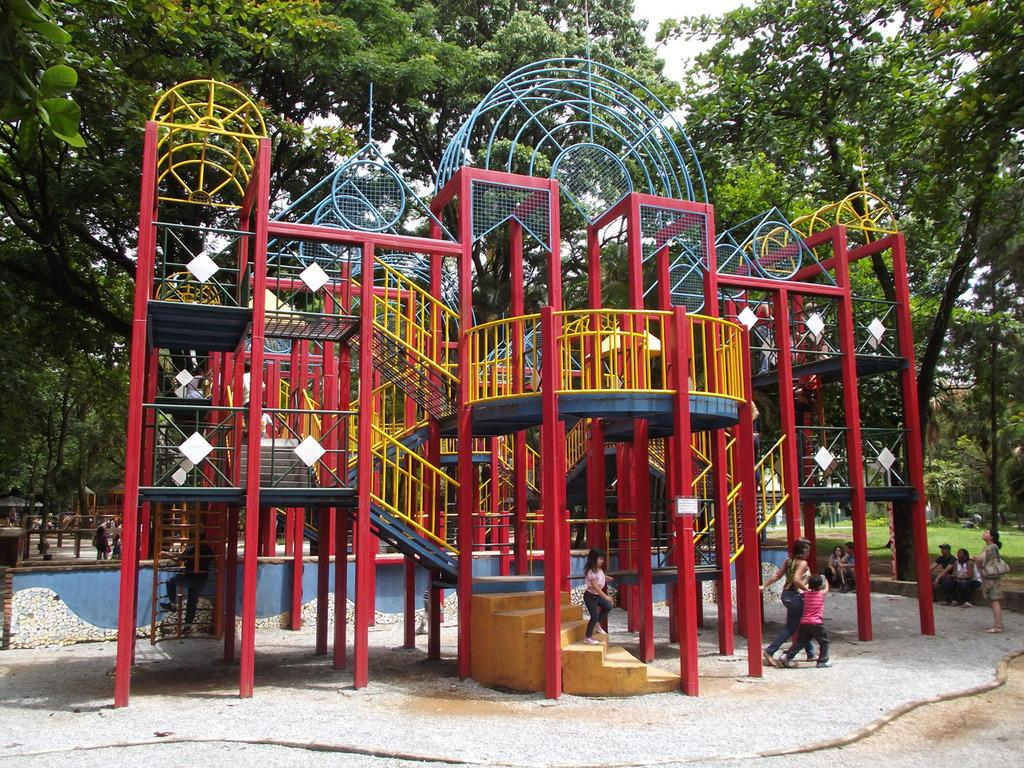What is the main subject of the image? The main subject of the image is a playground. Are there any people present in the image? Yes, there are people in the image. What can be seen in the background of the image? There are trees in the background of the image. What architectural feature is present in the image? There are stairs in the image. What is visible above the playground and trees? The sky is visible in the image. What type of bait is being used by the people in the image? There is no mention of bait or fishing in the image; it features a playground with people and trees. How many cherries are visible on the trees in the image? There are no cherries present in the image; it features trees without any specific fruit mentioned. 